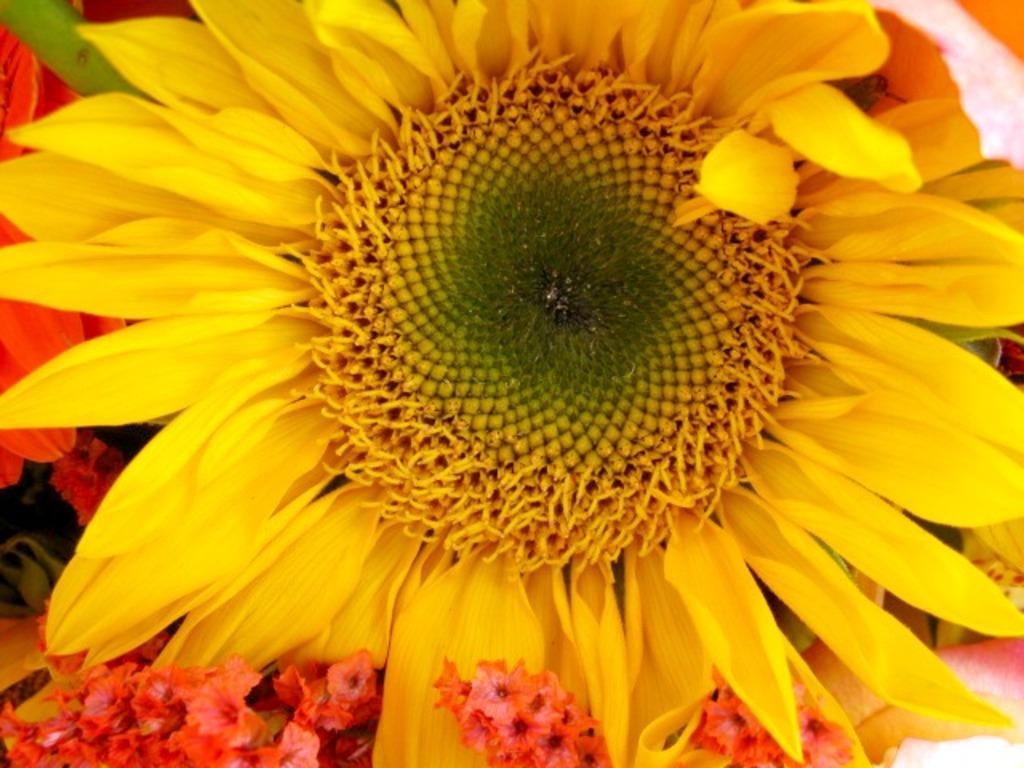Could you give a brief overview of what you see in this image? In this picture we can see a sunflower. At the bottom we can see red color flowers. 